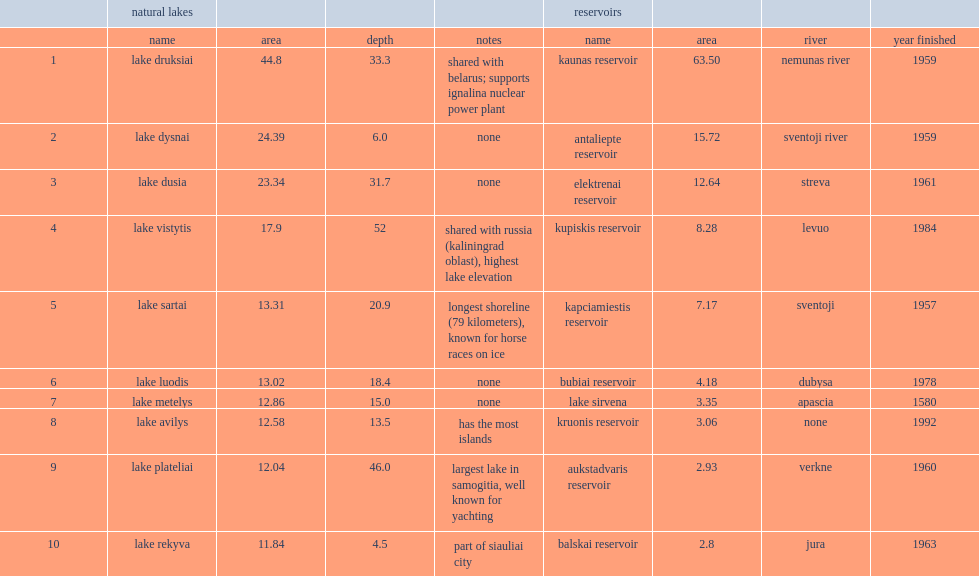What was lake dysnai's rank in lithuania? 2.0. 